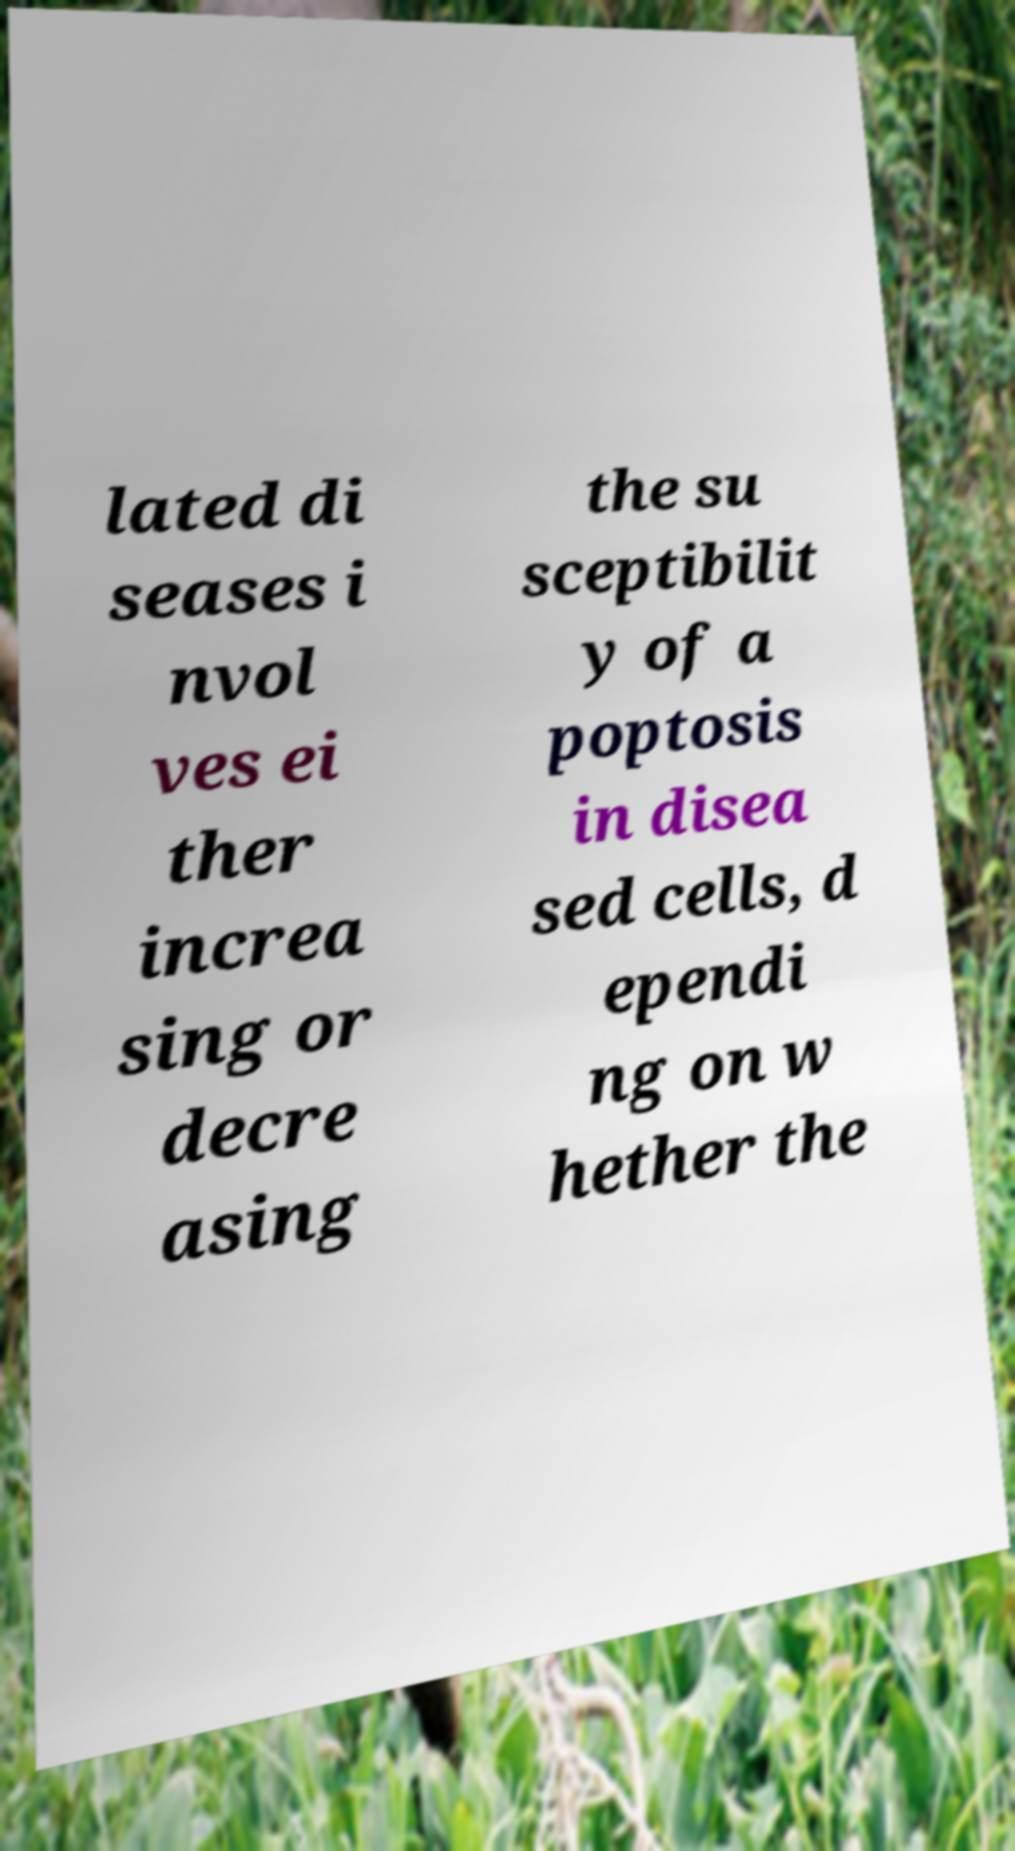Could you extract and type out the text from this image? lated di seases i nvol ves ei ther increa sing or decre asing the su sceptibilit y of a poptosis in disea sed cells, d ependi ng on w hether the 